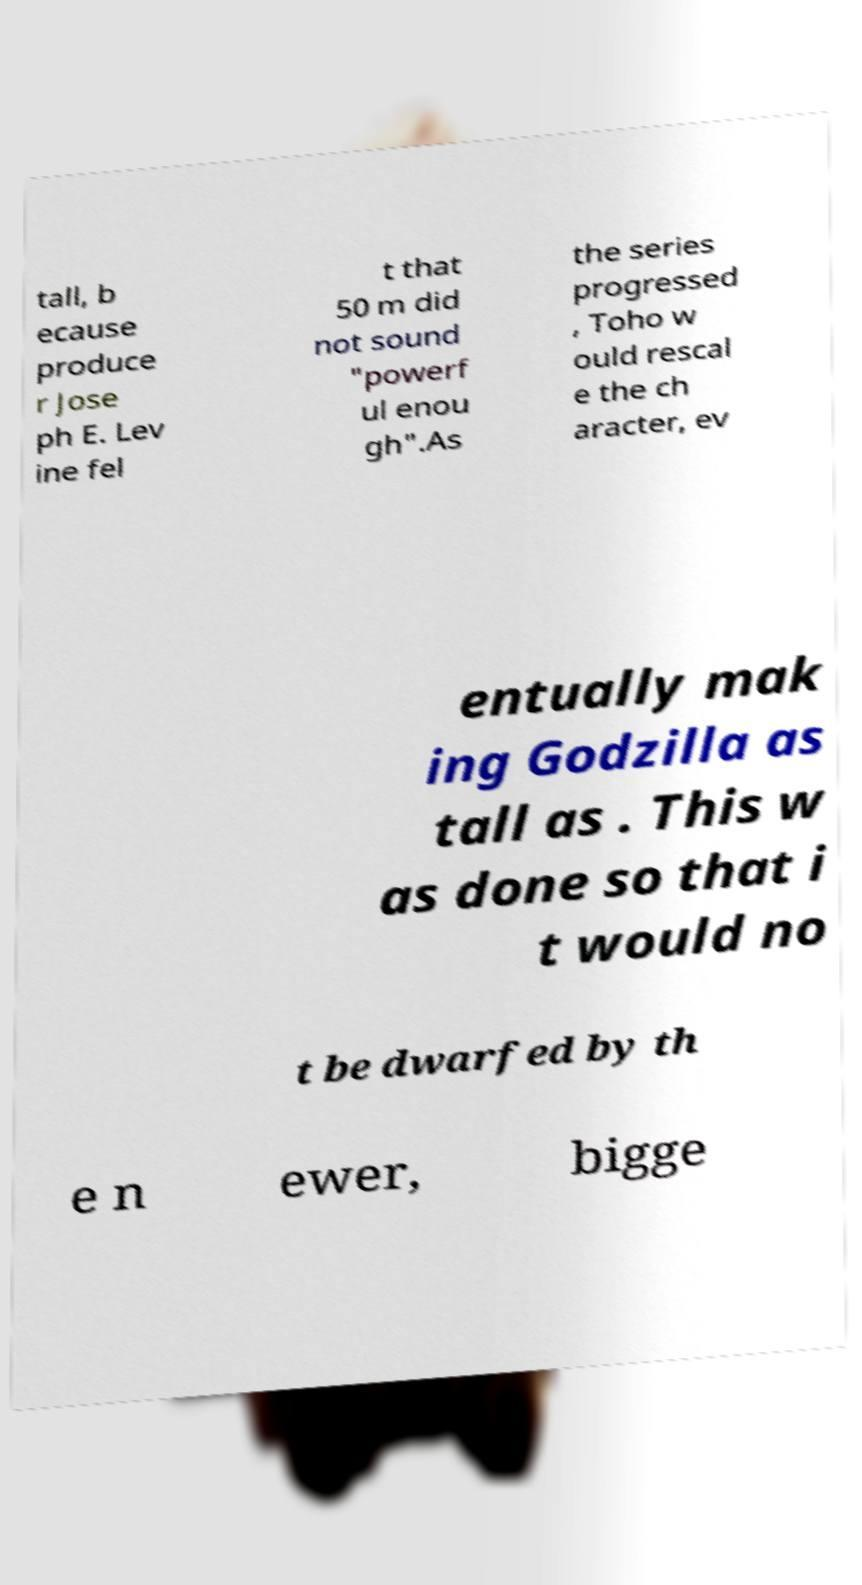Can you read and provide the text displayed in the image?This photo seems to have some interesting text. Can you extract and type it out for me? tall, b ecause produce r Jose ph E. Lev ine fel t that 50 m did not sound "powerf ul enou gh".As the series progressed , Toho w ould rescal e the ch aracter, ev entually mak ing Godzilla as tall as . This w as done so that i t would no t be dwarfed by th e n ewer, bigge 